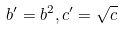<formula> <loc_0><loc_0><loc_500><loc_500>b ^ { \prime } = b ^ { 2 } , c ^ { \prime } = \sqrt { c }</formula> 